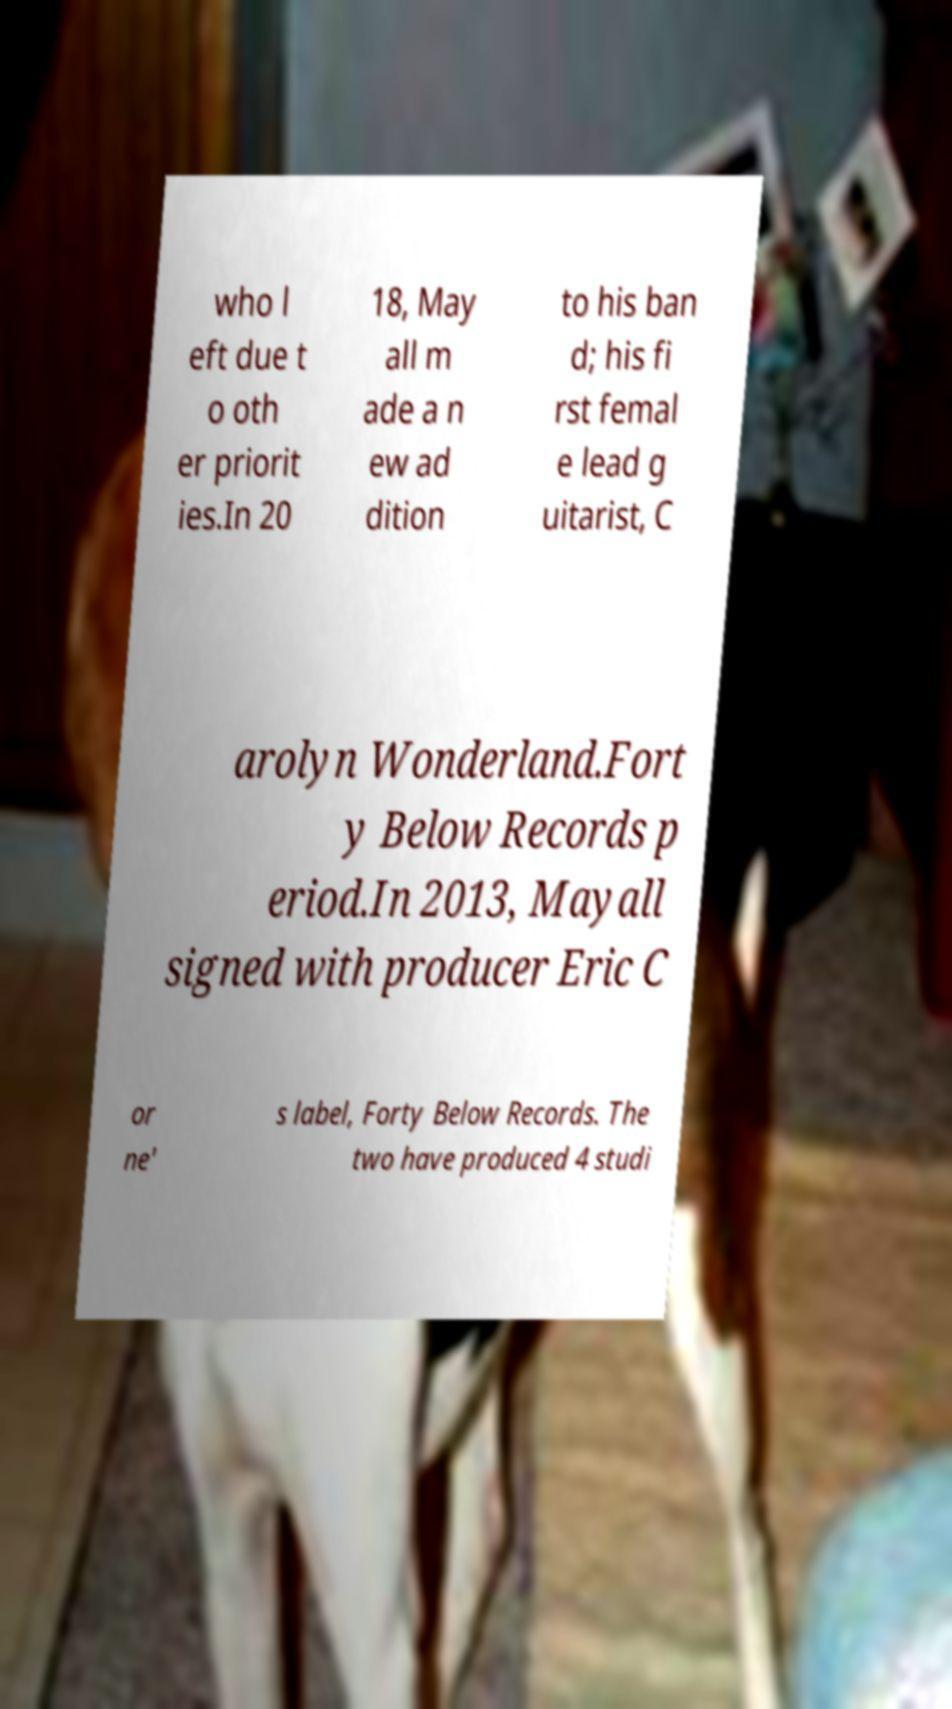There's text embedded in this image that I need extracted. Can you transcribe it verbatim? who l eft due t o oth er priorit ies.In 20 18, May all m ade a n ew ad dition to his ban d; his fi rst femal e lead g uitarist, C arolyn Wonderland.Fort y Below Records p eriod.In 2013, Mayall signed with producer Eric C or ne' s label, Forty Below Records. The two have produced 4 studi 